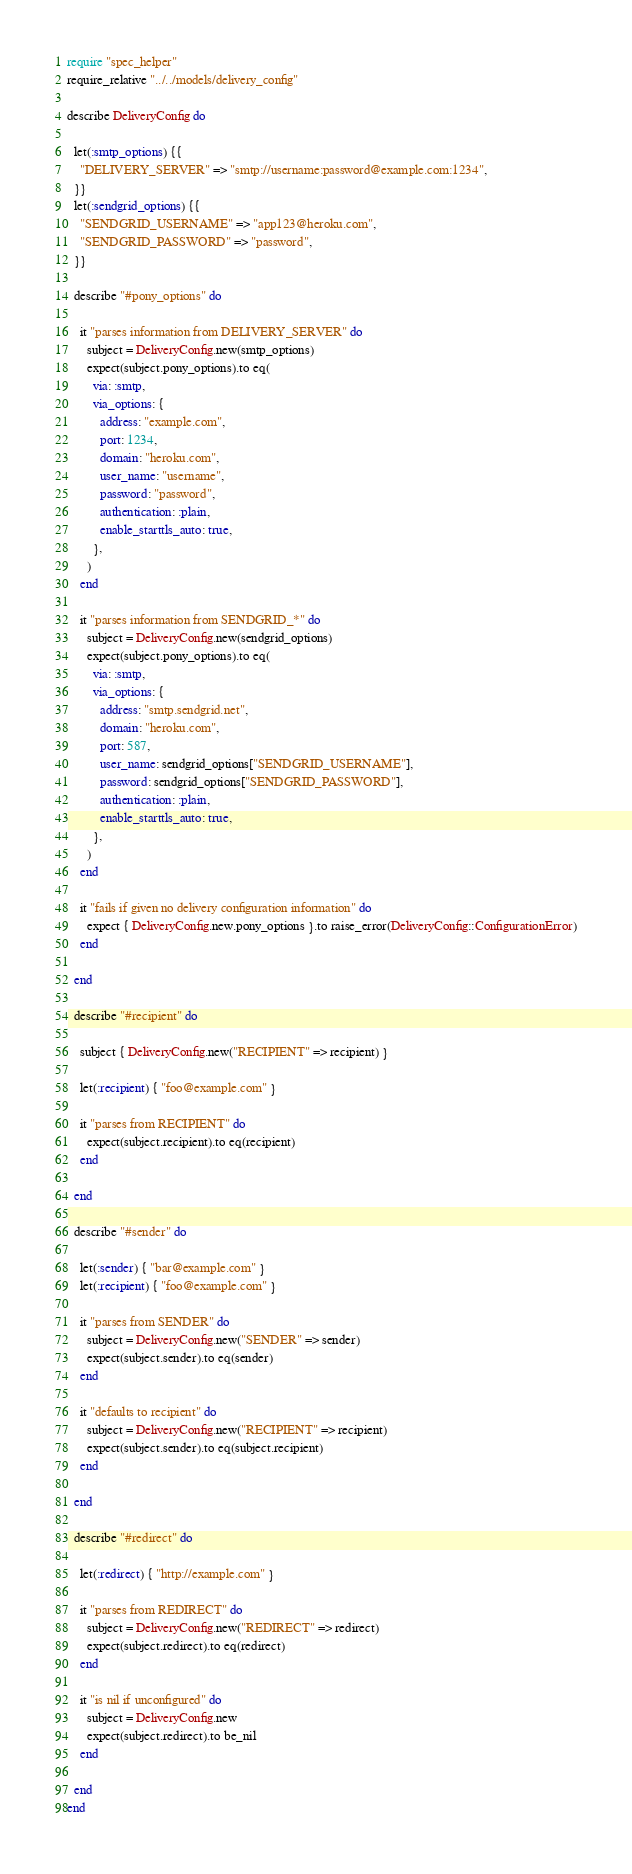Convert code to text. <code><loc_0><loc_0><loc_500><loc_500><_Ruby_>require "spec_helper"
require_relative "../../models/delivery_config"

describe DeliveryConfig do

  let(:smtp_options) {{
    "DELIVERY_SERVER" => "smtp://username:password@example.com:1234",
  }}
  let(:sendgrid_options) {{
    "SENDGRID_USERNAME" => "app123@heroku.com",
    "SENDGRID_PASSWORD" => "password",
  }}

  describe "#pony_options" do

    it "parses information from DELIVERY_SERVER" do
      subject = DeliveryConfig.new(smtp_options)
      expect(subject.pony_options).to eq(
        via: :smtp,
        via_options: {
          address: "example.com",
          port: 1234,
          domain: "heroku.com",
          user_name: "username",
          password: "password",
          authentication: :plain,
          enable_starttls_auto: true,
        },
      )
    end

    it "parses information from SENDGRID_*" do
      subject = DeliveryConfig.new(sendgrid_options)
      expect(subject.pony_options).to eq(
        via: :smtp,
        via_options: {
          address: "smtp.sendgrid.net",
          domain: "heroku.com",
          port: 587,
          user_name: sendgrid_options["SENDGRID_USERNAME"],
          password: sendgrid_options["SENDGRID_PASSWORD"],
          authentication: :plain,
          enable_starttls_auto: true,
        },
      )
    end

    it "fails if given no delivery configuration information" do
      expect { DeliveryConfig.new.pony_options }.to raise_error(DeliveryConfig::ConfigurationError)
    end

  end

  describe "#recipient" do

    subject { DeliveryConfig.new("RECIPIENT" => recipient) }

    let(:recipient) { "foo@example.com" }

    it "parses from RECIPIENT" do
      expect(subject.recipient).to eq(recipient)
    end

  end

  describe "#sender" do

    let(:sender) { "bar@example.com" }
    let(:recipient) { "foo@example.com" }

    it "parses from SENDER" do
      subject = DeliveryConfig.new("SENDER" => sender)
      expect(subject.sender).to eq(sender)
    end

    it "defaults to recipient" do
      subject = DeliveryConfig.new("RECIPIENT" => recipient)
      expect(subject.sender).to eq(subject.recipient)
    end

  end

  describe "#redirect" do

    let(:redirect) { "http://example.com" }

    it "parses from REDIRECT" do
      subject = DeliveryConfig.new("REDIRECT" => redirect)
      expect(subject.redirect).to eq(redirect)
    end

    it "is nil if unconfigured" do
      subject = DeliveryConfig.new
      expect(subject.redirect).to be_nil
    end

  end
end
</code> 